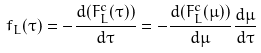<formula> <loc_0><loc_0><loc_500><loc_500>f _ { L } ( \tau ) = - \frac { d ( F ^ { c } _ { L } ( \tau ) ) } { d \tau } = - \frac { d ( F ^ { c } _ { L } ( \mu ) ) } { d \mu } \frac { d \mu } { d \tau }</formula> 